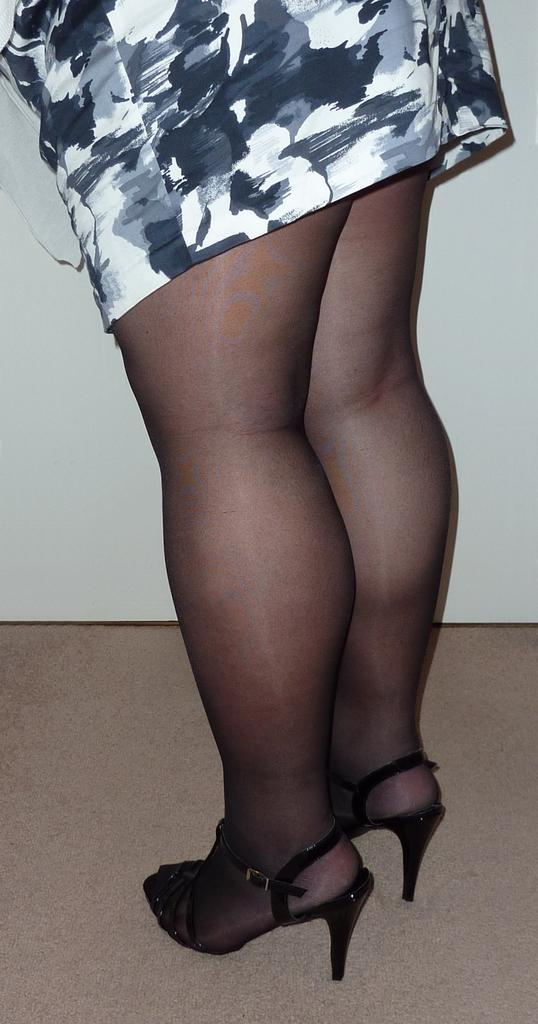Please provide a concise description of this image. In this image I can see the person with the footwear and the dress which is in white, black and grey color. And there is a white background. 